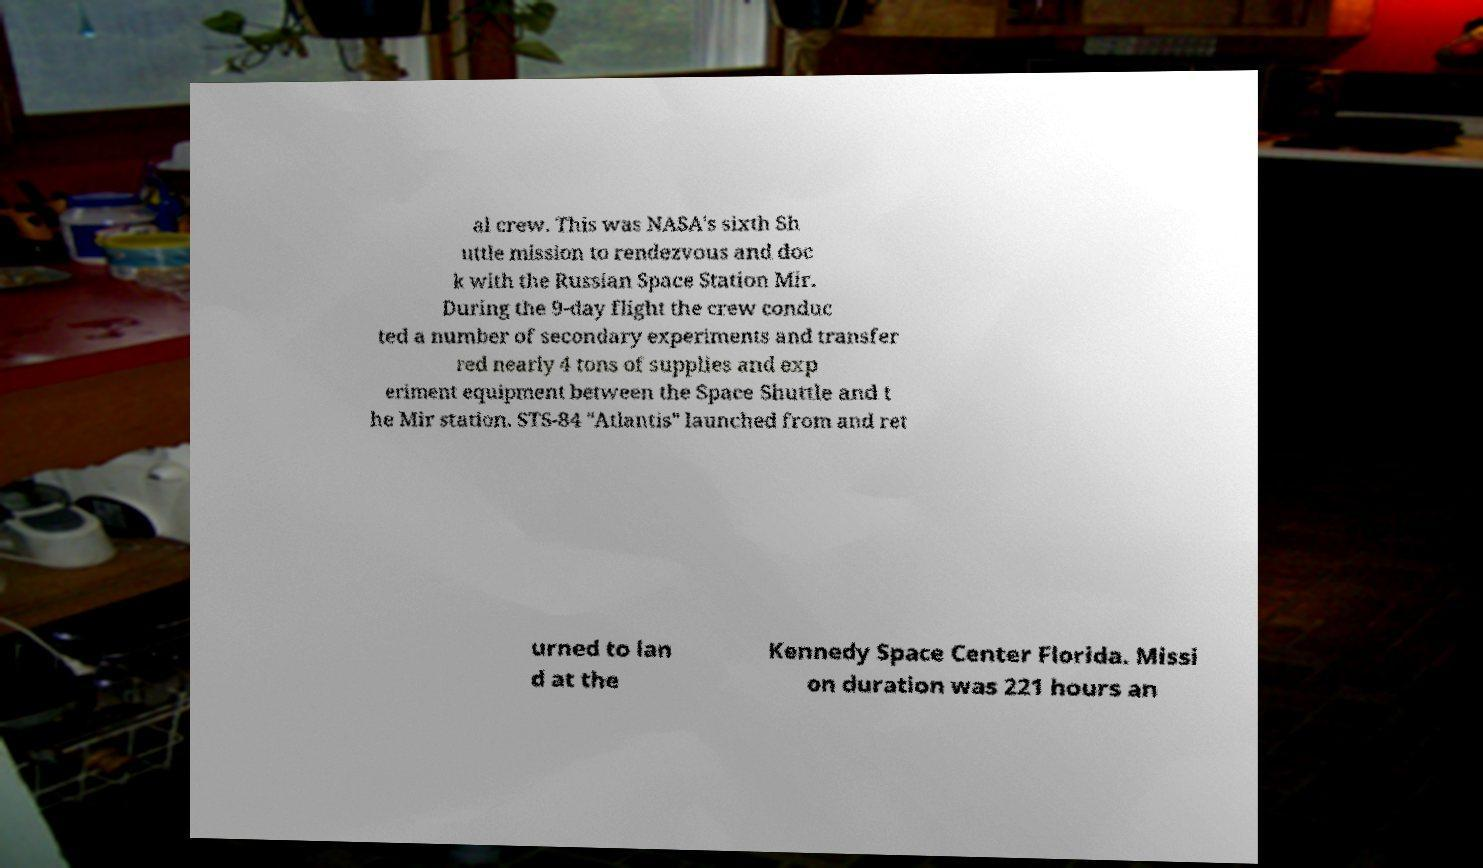Can you read and provide the text displayed in the image?This photo seems to have some interesting text. Can you extract and type it out for me? al crew. This was NASA's sixth Sh uttle mission to rendezvous and doc k with the Russian Space Station Mir. During the 9-day flight the crew conduc ted a number of secondary experiments and transfer red nearly 4 tons of supplies and exp eriment equipment between the Space Shuttle and t he Mir station. STS-84 "Atlantis" launched from and ret urned to lan d at the Kennedy Space Center Florida. Missi on duration was 221 hours an 